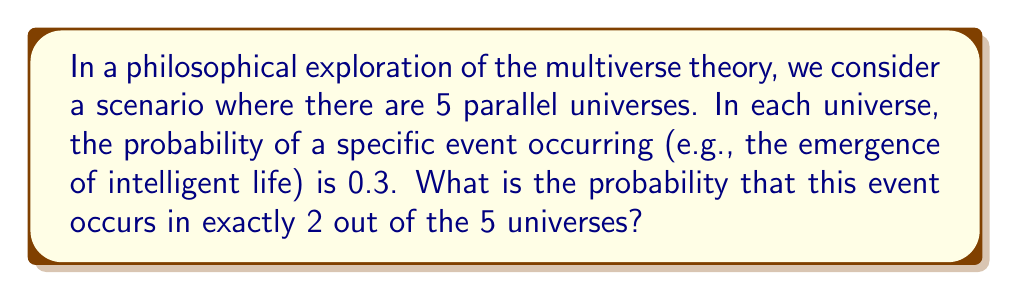Provide a solution to this math problem. To solve this problem, we can use the concept of binomial probability. This aligns with our philosophical exploration of random events in a multiverse scenario.

1) First, we identify the components of our binomial probability:
   - $n$ = number of trials (universes) = 5
   - $k$ = number of successes (universes where the event occurs) = 2
   - $p$ = probability of success in each trial = 0.3
   - $q$ = probability of failure in each trial = 1 - p = 0.7

2) The binomial probability formula is:

   $$P(X = k) = \binom{n}{k} p^k q^{n-k}$$

3) We calculate $\binom{n}{k}$, which represents the number of ways to choose $k$ items from $n$ items:

   $$\binom{5}{2} = \frac{5!}{2!(5-2)!} = \frac{5 \cdot 4}{2 \cdot 1} = 10$$

4) Now we can plug everything into our formula:

   $$P(X = 2) = 10 \cdot (0.3)^2 \cdot (0.7)^{5-2}$$

5) Simplify:
   $$P(X = 2) = 10 \cdot 0.09 \cdot 0.343 = 0.3087$$

This result represents the probability of the event occurring in exactly 2 out of 5 universes, given our initial assumptions.
Answer: The probability is approximately 0.3087 or 30.87%. 